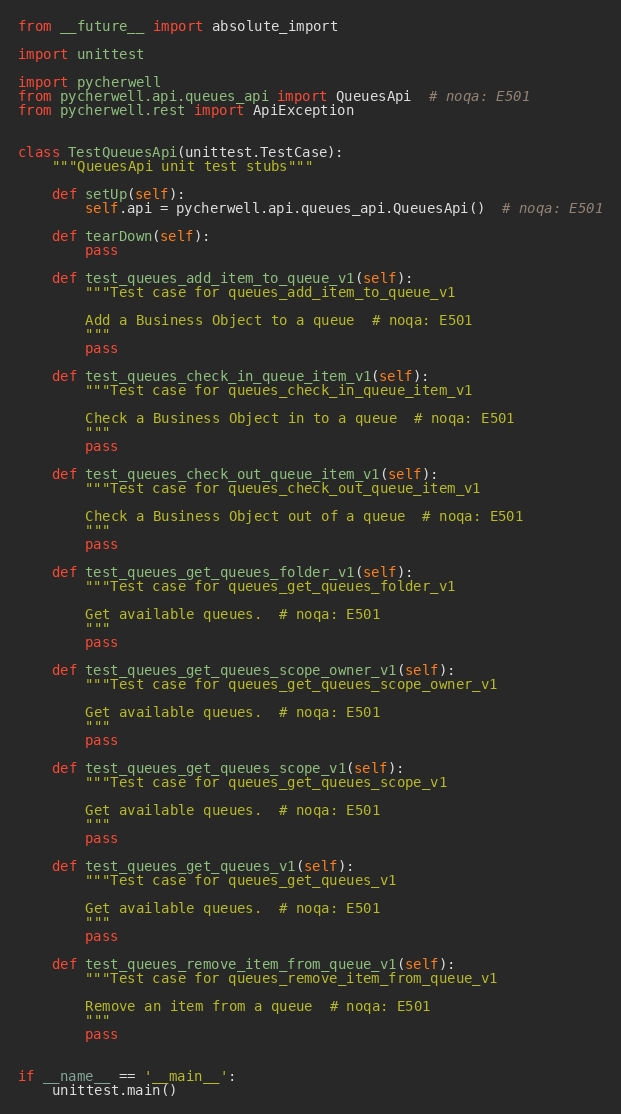Convert code to text. <code><loc_0><loc_0><loc_500><loc_500><_Python_>
from __future__ import absolute_import

import unittest

import pycherwell
from pycherwell.api.queues_api import QueuesApi  # noqa: E501
from pycherwell.rest import ApiException


class TestQueuesApi(unittest.TestCase):
    """QueuesApi unit test stubs"""

    def setUp(self):
        self.api = pycherwell.api.queues_api.QueuesApi()  # noqa: E501

    def tearDown(self):
        pass

    def test_queues_add_item_to_queue_v1(self):
        """Test case for queues_add_item_to_queue_v1

        Add a Business Object to a queue  # noqa: E501
        """
        pass

    def test_queues_check_in_queue_item_v1(self):
        """Test case for queues_check_in_queue_item_v1

        Check a Business Object in to a queue  # noqa: E501
        """
        pass

    def test_queues_check_out_queue_item_v1(self):
        """Test case for queues_check_out_queue_item_v1

        Check a Business Object out of a queue  # noqa: E501
        """
        pass

    def test_queues_get_queues_folder_v1(self):
        """Test case for queues_get_queues_folder_v1

        Get available queues.  # noqa: E501
        """
        pass

    def test_queues_get_queues_scope_owner_v1(self):
        """Test case for queues_get_queues_scope_owner_v1

        Get available queues.  # noqa: E501
        """
        pass

    def test_queues_get_queues_scope_v1(self):
        """Test case for queues_get_queues_scope_v1

        Get available queues.  # noqa: E501
        """
        pass

    def test_queues_get_queues_v1(self):
        """Test case for queues_get_queues_v1

        Get available queues.  # noqa: E501
        """
        pass

    def test_queues_remove_item_from_queue_v1(self):
        """Test case for queues_remove_item_from_queue_v1

        Remove an item from a queue  # noqa: E501
        """
        pass


if __name__ == '__main__':
    unittest.main()
</code> 